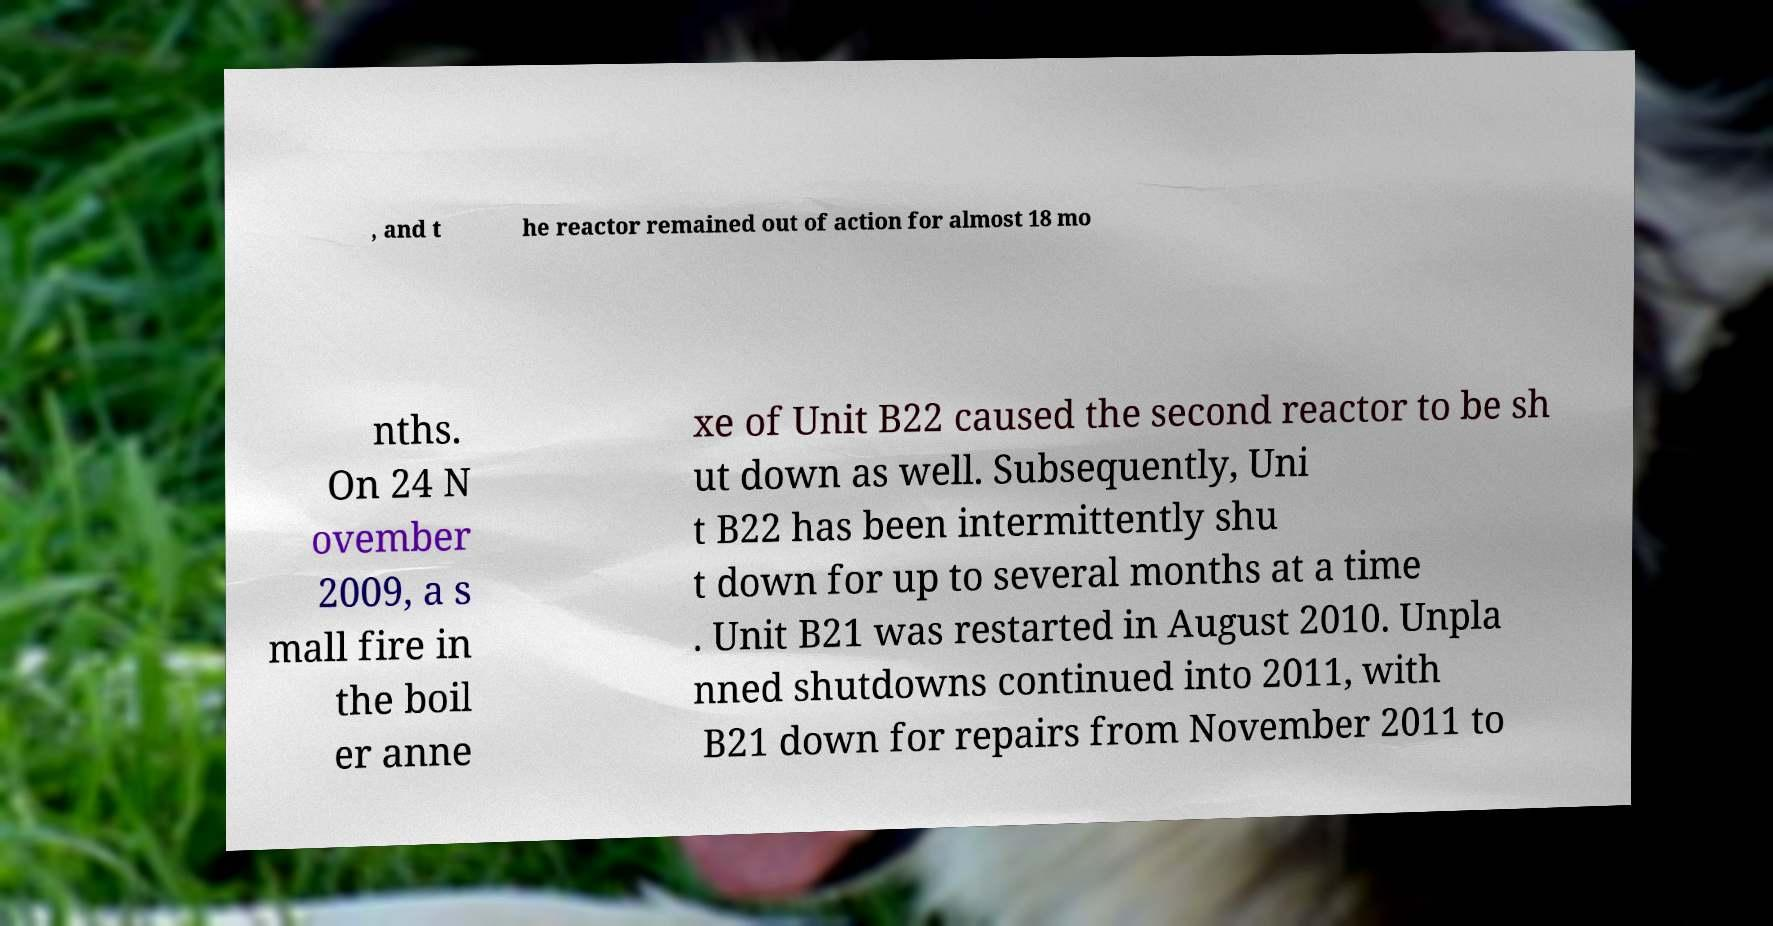Can you read and provide the text displayed in the image?This photo seems to have some interesting text. Can you extract and type it out for me? , and t he reactor remained out of action for almost 18 mo nths. On 24 N ovember 2009, a s mall fire in the boil er anne xe of Unit B22 caused the second reactor to be sh ut down as well. Subsequently, Uni t B22 has been intermittently shu t down for up to several months at a time . Unit B21 was restarted in August 2010. Unpla nned shutdowns continued into 2011, with B21 down for repairs from November 2011 to 